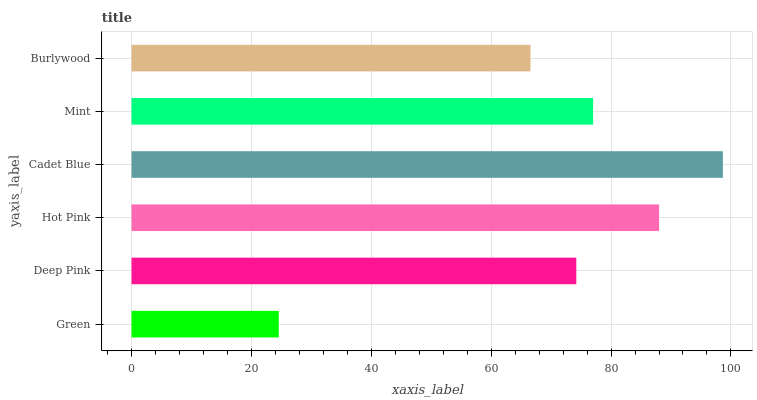Is Green the minimum?
Answer yes or no. Yes. Is Cadet Blue the maximum?
Answer yes or no. Yes. Is Deep Pink the minimum?
Answer yes or no. No. Is Deep Pink the maximum?
Answer yes or no. No. Is Deep Pink greater than Green?
Answer yes or no. Yes. Is Green less than Deep Pink?
Answer yes or no. Yes. Is Green greater than Deep Pink?
Answer yes or no. No. Is Deep Pink less than Green?
Answer yes or no. No. Is Mint the high median?
Answer yes or no. Yes. Is Deep Pink the low median?
Answer yes or no. Yes. Is Deep Pink the high median?
Answer yes or no. No. Is Mint the low median?
Answer yes or no. No. 